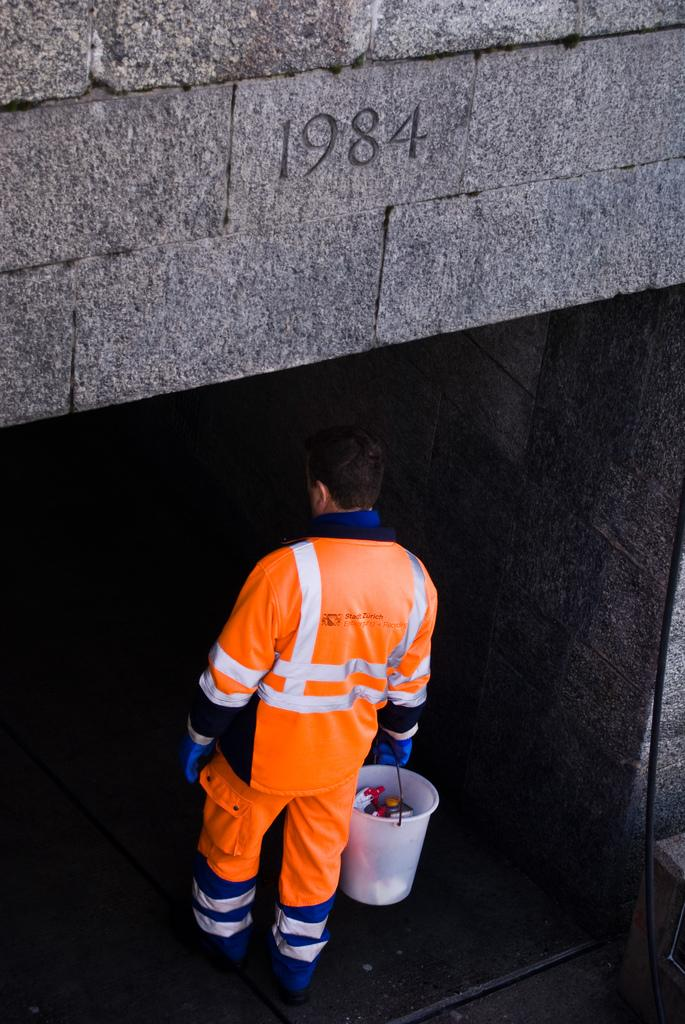<image>
Describe the image concisely. A man in an orange work uniform is carrying a bucket into a stone tunnel with 1984 carved in the archway. 